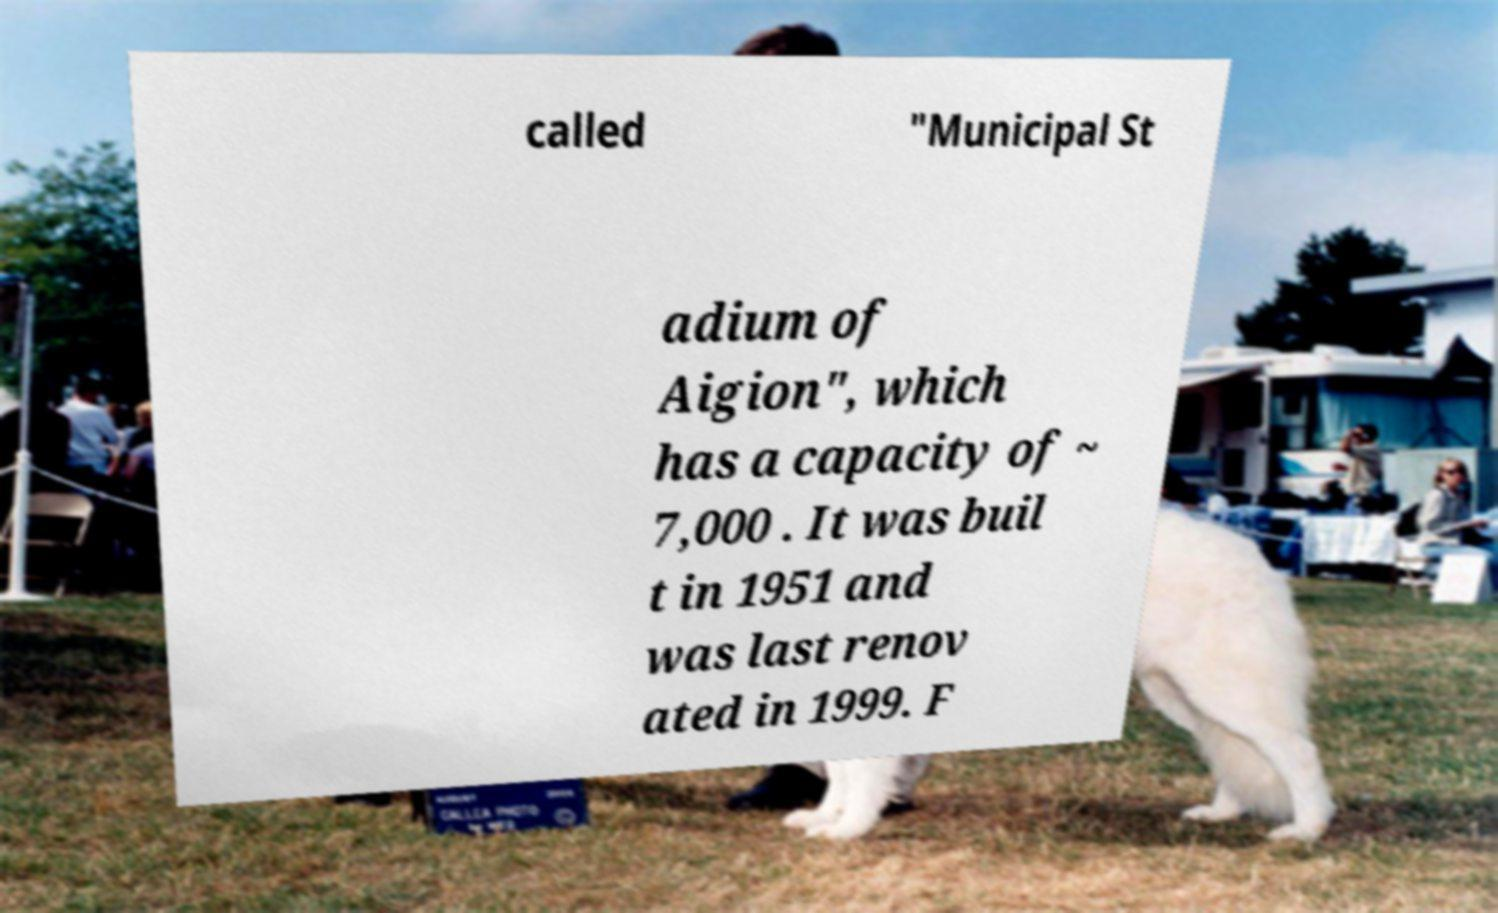Can you read and provide the text displayed in the image?This photo seems to have some interesting text. Can you extract and type it out for me? called "Municipal St adium of Aigion", which has a capacity of ~ 7,000 . It was buil t in 1951 and was last renov ated in 1999. F 